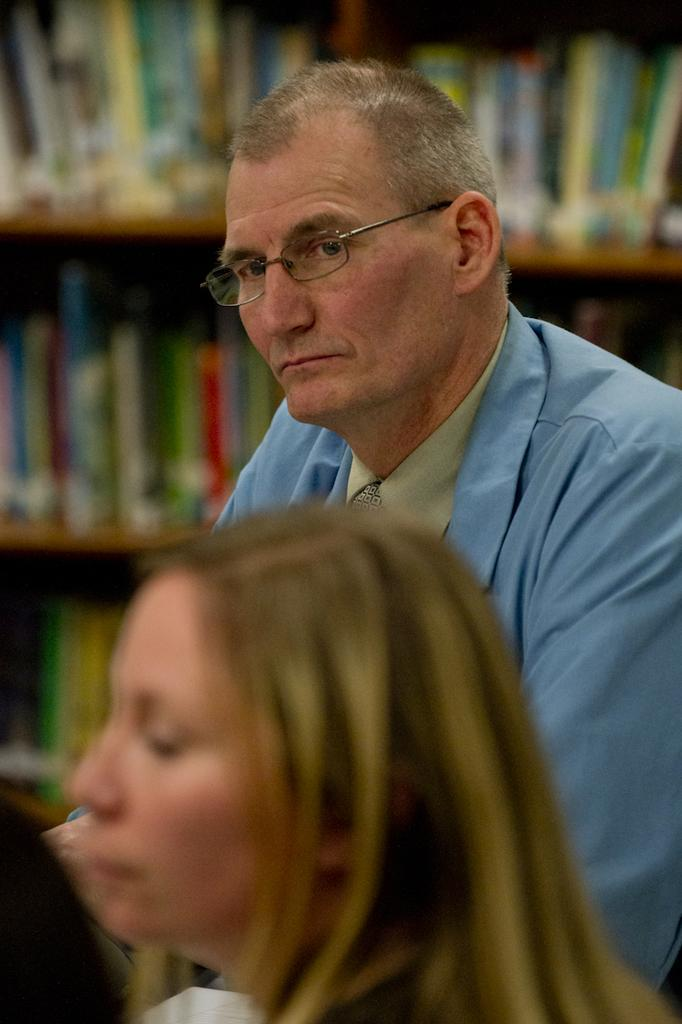How many people are in the group shown in the image? There is a group of people in the image. Can you describe the appearance of one of the men in the group? One man in the group is wearing a blue shirt and spectacles. What can be seen in the background of the image? There is a background with a group of books placed in a rack. How much wealth does the man in the blue shirt have, as indicated by the image? The image does not provide any information about the man's wealth, so it cannot be determined from the image. What type of trousers is the man in the blue shirt wearing? The image does not show the man's trousers, so it cannot be determined from the image. 